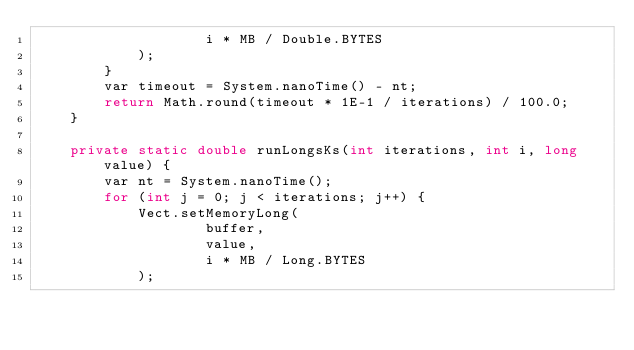Convert code to text. <code><loc_0><loc_0><loc_500><loc_500><_Java_>                    i * MB / Double.BYTES
            );
        }
        var timeout = System.nanoTime() - nt;
        return Math.round(timeout * 1E-1 / iterations) / 100.0;
    }

    private static double runLongsKs(int iterations, int i, long value) {
        var nt = System.nanoTime();
        for (int j = 0; j < iterations; j++) {
            Vect.setMemoryLong(
                    buffer,
                    value,
                    i * MB / Long.BYTES
            );</code> 